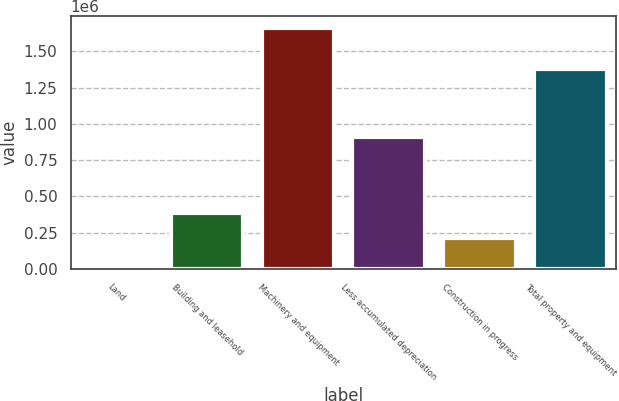Convert chart. <chart><loc_0><loc_0><loc_500><loc_500><bar_chart><fcel>Land<fcel>Building and leasehold<fcel>Machinery and equipment<fcel>Less accumulated depreciation<fcel>Construction in progress<fcel>Total property and equipment<nl><fcel>23778<fcel>389234<fcel>1.66014e+06<fcel>911910<fcel>212872<fcel>1.37411e+06<nl></chart> 